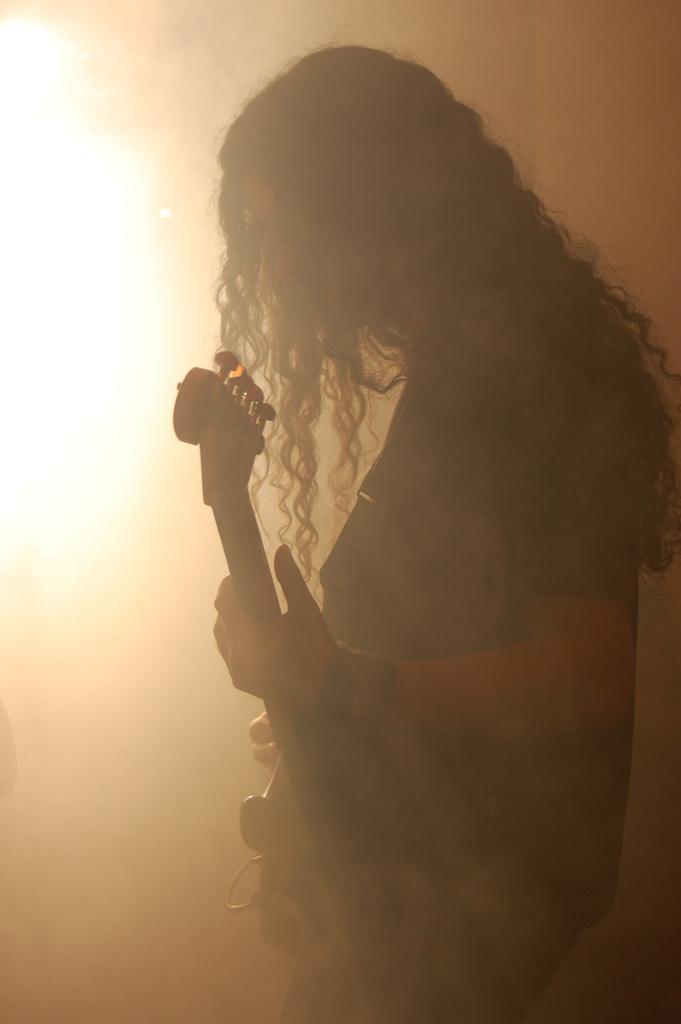Who is the main subject in the image? There is a man in the image. Can you describe the man's appearance? The man has long hair. What is the man holding in the image? The man is holding a guitar. What can be seen illuminating the man in the image? There is a light shining in front of the man. What type of minister can be seen in the field in the image? There is no minister or field present in the image; it features a man holding a guitar with a light shining in front of him. What branch of the military is the man in the image a part of? There is no indication of the man being in the military or belonging to a specific branch in the image. 